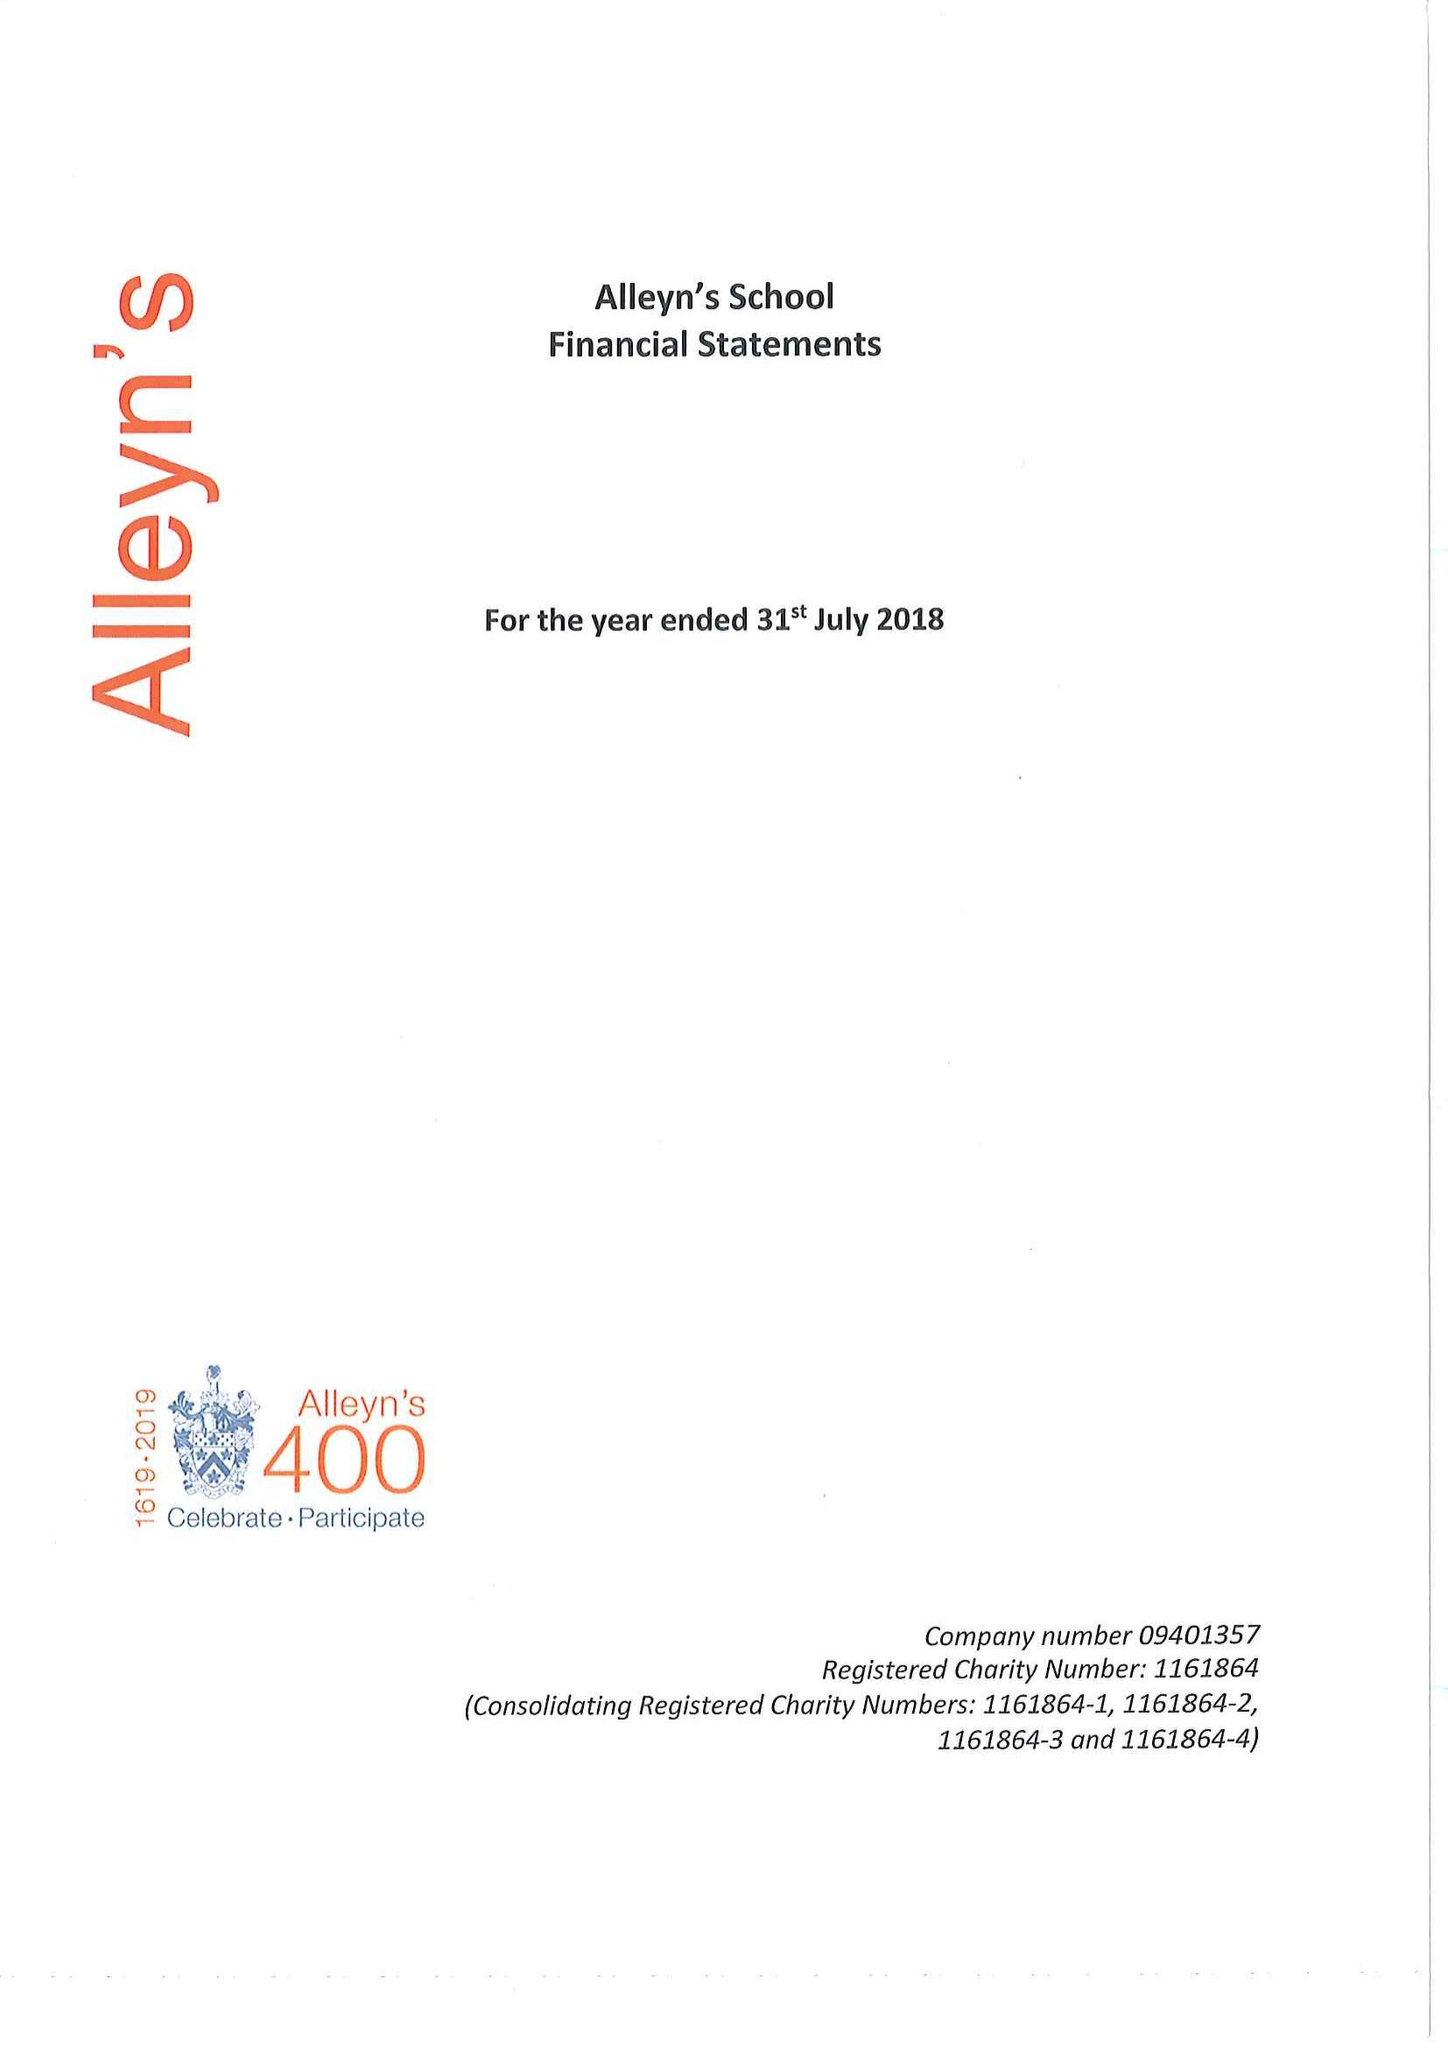What is the value for the address__street_line?
Answer the question using a single word or phrase. TOWNLEY ROAD 